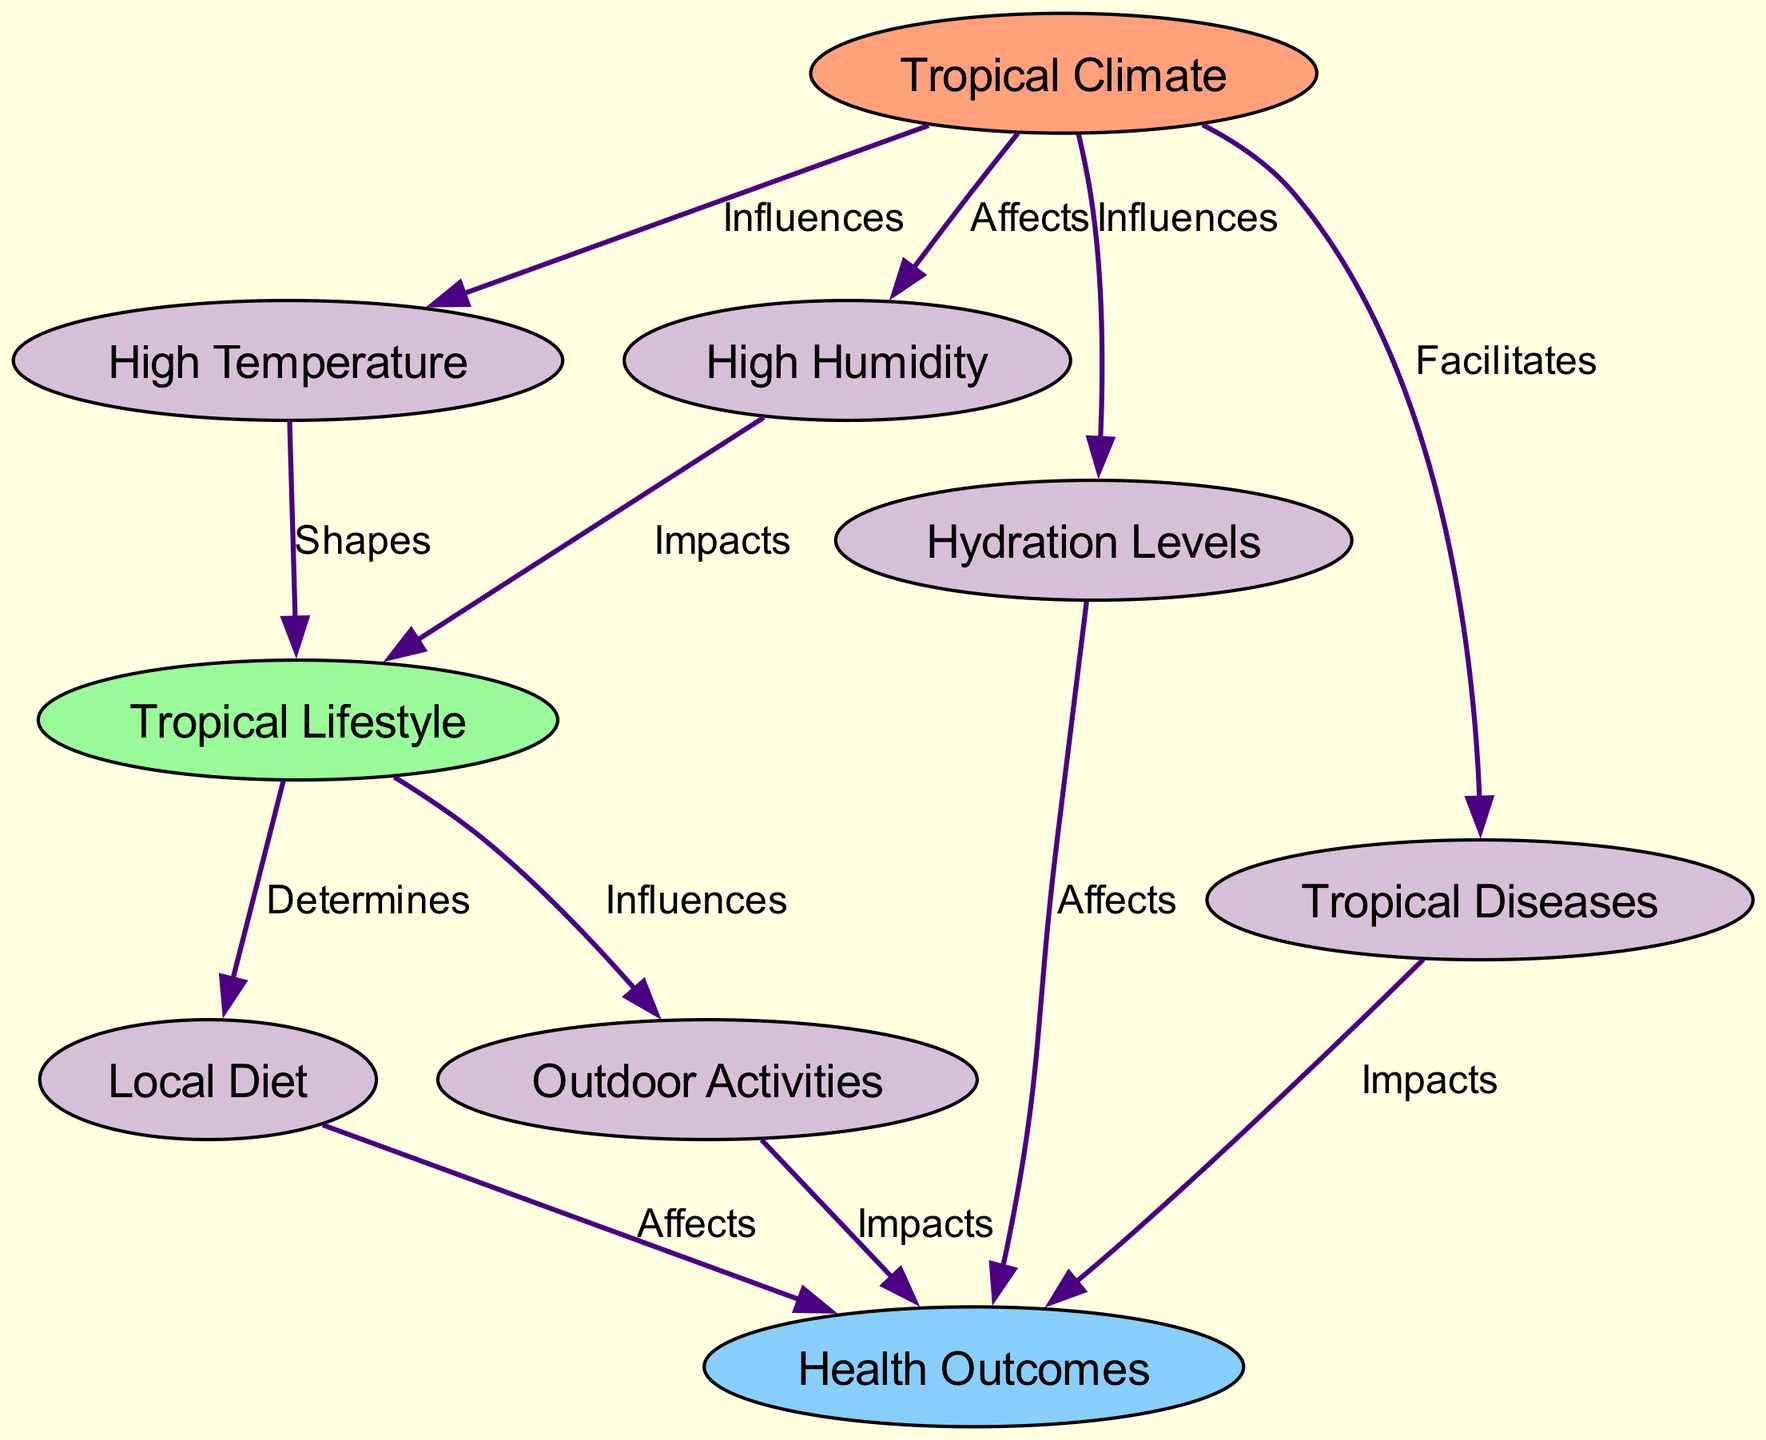What are the two main climate factors in this diagram? The diagram explicitly lists "High Temperature" and "High Humidity" as nodes under the "Tropical Climate" category.
Answer: High Temperature, High Humidity How many nodes are there in total? By counting each unique node defined in the "nodes" section, there are a total of 8 distinct nodes.
Answer: 8 Which node influences the "Health Outcomes"? The diagram shows the "Hydration Levels" and "Tropical Diseases" as factors that both flow into "Health Outcomes," but "Hydration Levels" and "diseases" are both influenced directly by other nodes as well.
Answer: Hydration Levels, Tropical Diseases What relationship does the "Tropical Climate" have with "Diseases"? The edge labeled "Facilitates" connects "Tropical Climate" to "Tropical Diseases," indicating a causal relationship where the climate supports the prevalence of these diseases.
Answer: Facilitates How does "High Humidity" affect lifestyle? The diagram indicates that "High Humidity" has an edge labeled "Impacts" directed towards "Tropical Lifestyle," meaning it directly influences how people adapt their lifestyle.
Answer: Impacts What is the outcome of the local diet on health? The edge from "Local Diet" to "Health Outcomes" is labeled "Affects," which suggests that the diet directly influences overall health.
Answer: Affects Which two lifestyle factors are influenced by lifestyle itself? The diagram indicates that "Local Diet" and "Outdoor Activities" are both influenced by "Tropical Lifestyle," depicting the interconnectedness of lifestyle choices.
Answer: Local Diet, Outdoor Activities How does "High Temperature" influence lifestyle? The connection labeled "Shapes" leads from "High Temperature" to "Tropical Lifestyle," indicating that temperature conditions determine how individuals choose to live.
Answer: Shapes Which node acts as a bridge between "Climate" and "Health"? "Hydration Levels" serves as a connector in the diagram, influenced by climate factors and directly affecting health outcomes.
Answer: Hydration Levels 